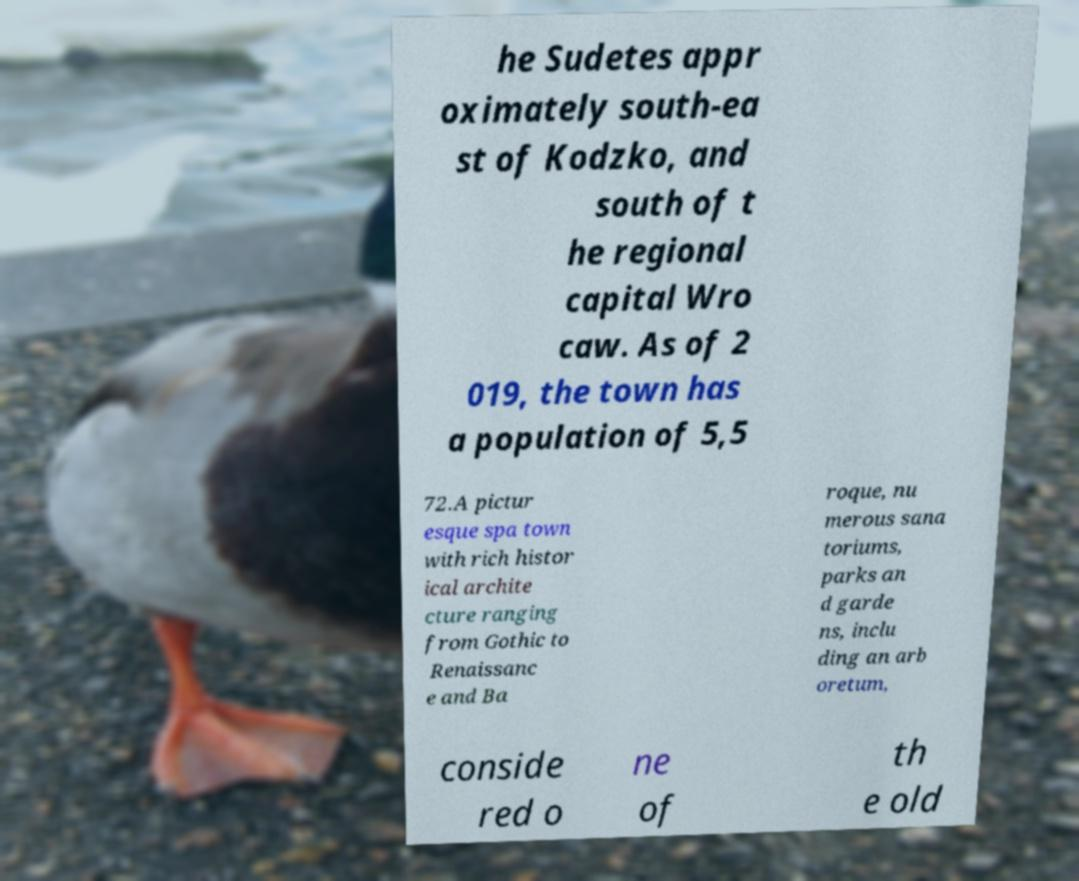Could you assist in decoding the text presented in this image and type it out clearly? he Sudetes appr oximately south-ea st of Kodzko, and south of t he regional capital Wro caw. As of 2 019, the town has a population of 5,5 72.A pictur esque spa town with rich histor ical archite cture ranging from Gothic to Renaissanc e and Ba roque, nu merous sana toriums, parks an d garde ns, inclu ding an arb oretum, conside red o ne of th e old 